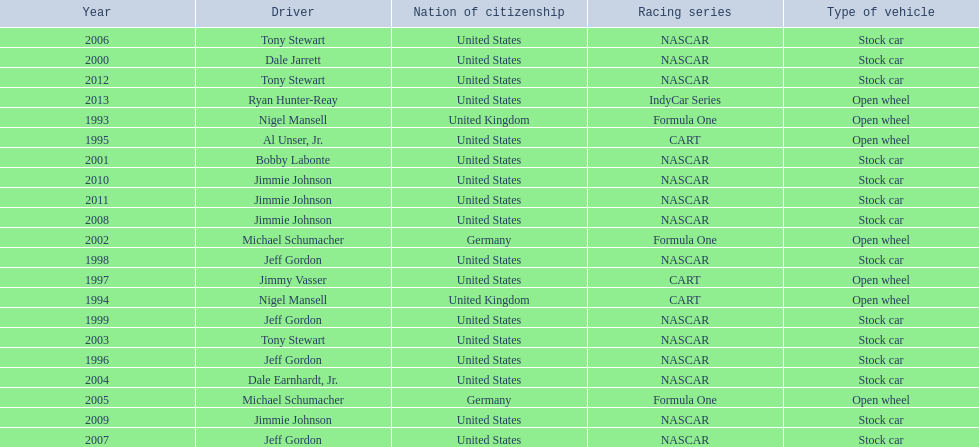Besides nascar, what other racing series have espy-winning drivers come from? Formula One, CART, IndyCar Series. Write the full table. {'header': ['Year', 'Driver', 'Nation of citizenship', 'Racing series', 'Type of vehicle'], 'rows': [['2006', 'Tony Stewart', 'United States', 'NASCAR', 'Stock car'], ['2000', 'Dale Jarrett', 'United States', 'NASCAR', 'Stock car'], ['2012', 'Tony Stewart', 'United States', 'NASCAR', 'Stock car'], ['2013', 'Ryan Hunter-Reay', 'United States', 'IndyCar Series', 'Open wheel'], ['1993', 'Nigel Mansell', 'United Kingdom', 'Formula One', 'Open wheel'], ['1995', 'Al Unser, Jr.', 'United States', 'CART', 'Open wheel'], ['2001', 'Bobby Labonte', 'United States', 'NASCAR', 'Stock car'], ['2010', 'Jimmie Johnson', 'United States', 'NASCAR', 'Stock car'], ['2011', 'Jimmie Johnson', 'United States', 'NASCAR', 'Stock car'], ['2008', 'Jimmie Johnson', 'United States', 'NASCAR', 'Stock car'], ['2002', 'Michael Schumacher', 'Germany', 'Formula One', 'Open wheel'], ['1998', 'Jeff Gordon', 'United States', 'NASCAR', 'Stock car'], ['1997', 'Jimmy Vasser', 'United States', 'CART', 'Open wheel'], ['1994', 'Nigel Mansell', 'United Kingdom', 'CART', 'Open wheel'], ['1999', 'Jeff Gordon', 'United States', 'NASCAR', 'Stock car'], ['2003', 'Tony Stewart', 'United States', 'NASCAR', 'Stock car'], ['1996', 'Jeff Gordon', 'United States', 'NASCAR', 'Stock car'], ['2004', 'Dale Earnhardt, Jr.', 'United States', 'NASCAR', 'Stock car'], ['2005', 'Michael Schumacher', 'Germany', 'Formula One', 'Open wheel'], ['2009', 'Jimmie Johnson', 'United States', 'NASCAR', 'Stock car'], ['2007', 'Jeff Gordon', 'United States', 'NASCAR', 'Stock car']]} 